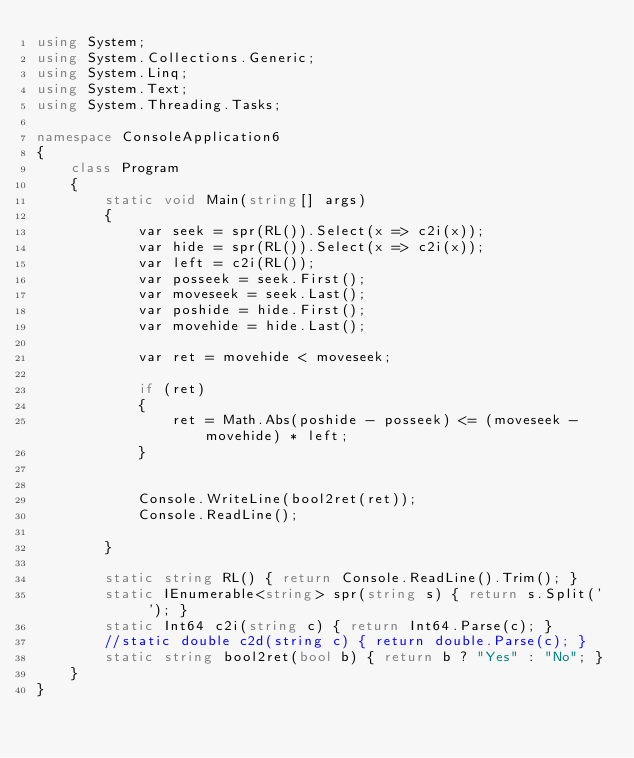<code> <loc_0><loc_0><loc_500><loc_500><_C#_>using System;
using System.Collections.Generic;
using System.Linq;
using System.Text;
using System.Threading.Tasks;

namespace ConsoleApplication6
{
    class Program
    {
        static void Main(string[] args)
        {
            var seek = spr(RL()).Select(x => c2i(x));
            var hide = spr(RL()).Select(x => c2i(x));
            var left = c2i(RL());
            var posseek = seek.First();
            var moveseek = seek.Last();
            var poshide = hide.First();
            var movehide = hide.Last();

            var ret = movehide < moveseek;

            if (ret)
            {
                ret = Math.Abs(poshide - posseek) <= (moveseek - movehide) * left;
            }


            Console.WriteLine(bool2ret(ret));
            Console.ReadLine();

        }

        static string RL() { return Console.ReadLine().Trim(); }
        static IEnumerable<string> spr(string s) { return s.Split(' '); }
        static Int64 c2i(string c) { return Int64.Parse(c); }
        //static double c2d(string c) { return double.Parse(c); }
        static string bool2ret(bool b) { return b ? "Yes" : "No"; }
    }
}</code> 